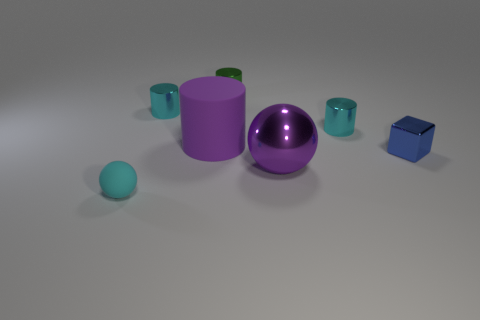How many objects in total are there in the image? The image showcases a total of seven objects. 